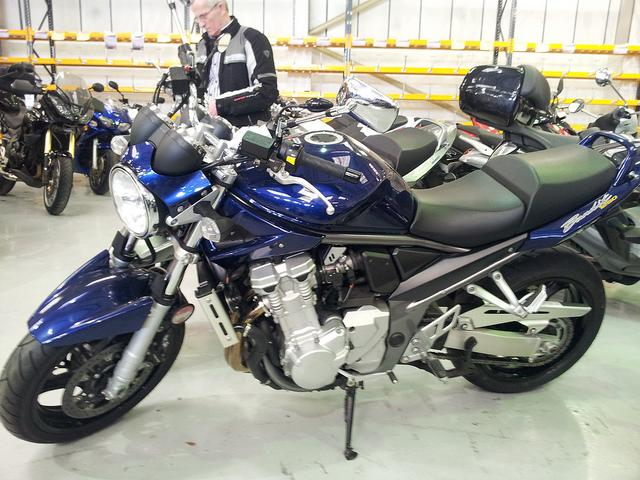What is he doing?

Choices:
A) stealing motorcycles
B) riding motorcycle
C) selling motorcycles
D) viewing motorcycles viewing motorcycles 